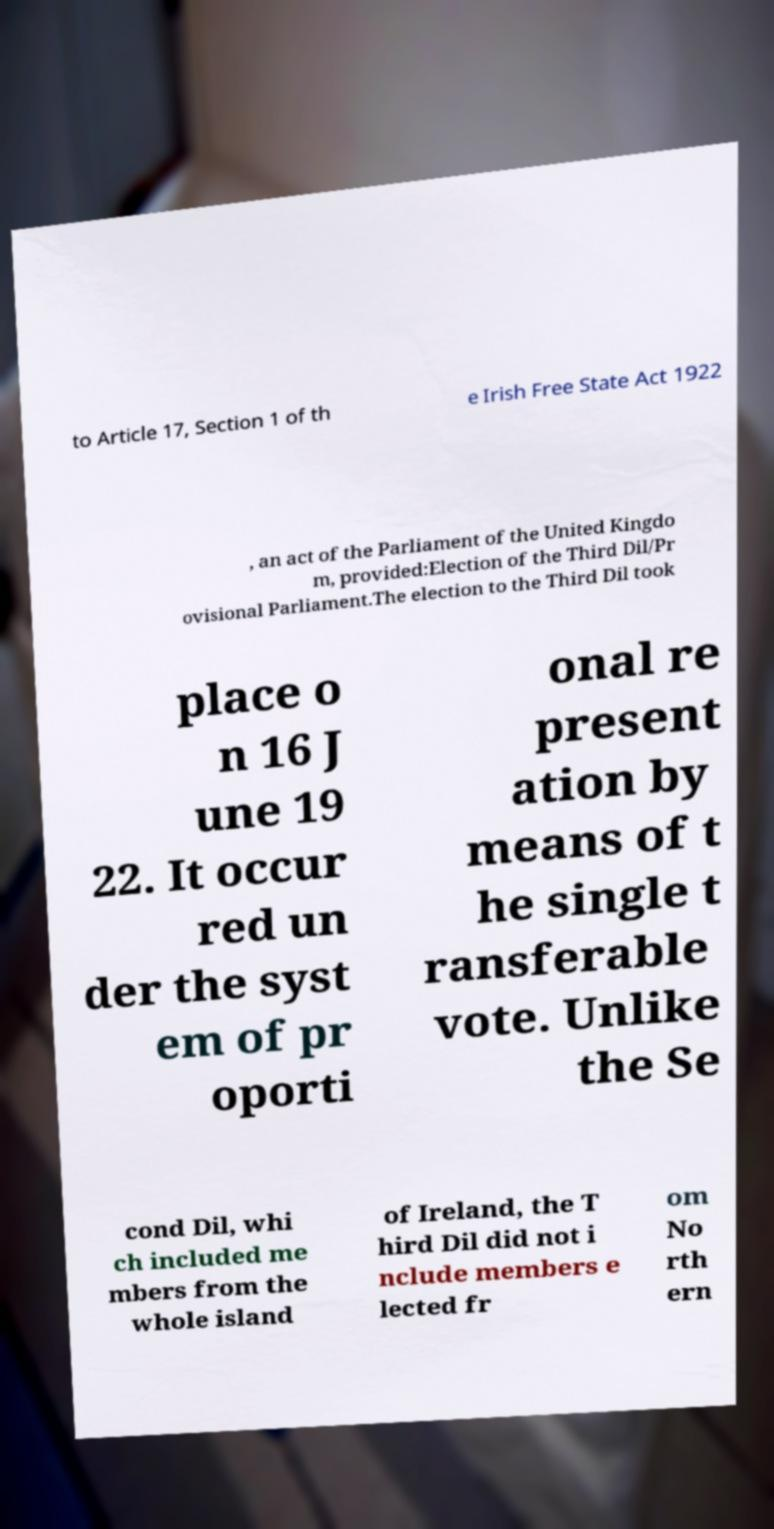Could you extract and type out the text from this image? to Article 17, Section 1 of th e Irish Free State Act 1922 , an act of the Parliament of the United Kingdo m, provided:Election of the Third Dil/Pr ovisional Parliament.The election to the Third Dil took place o n 16 J une 19 22. It occur red un der the syst em of pr oporti onal re present ation by means of t he single t ransferable vote. Unlike the Se cond Dil, whi ch included me mbers from the whole island of Ireland, the T hird Dil did not i nclude members e lected fr om No rth ern 